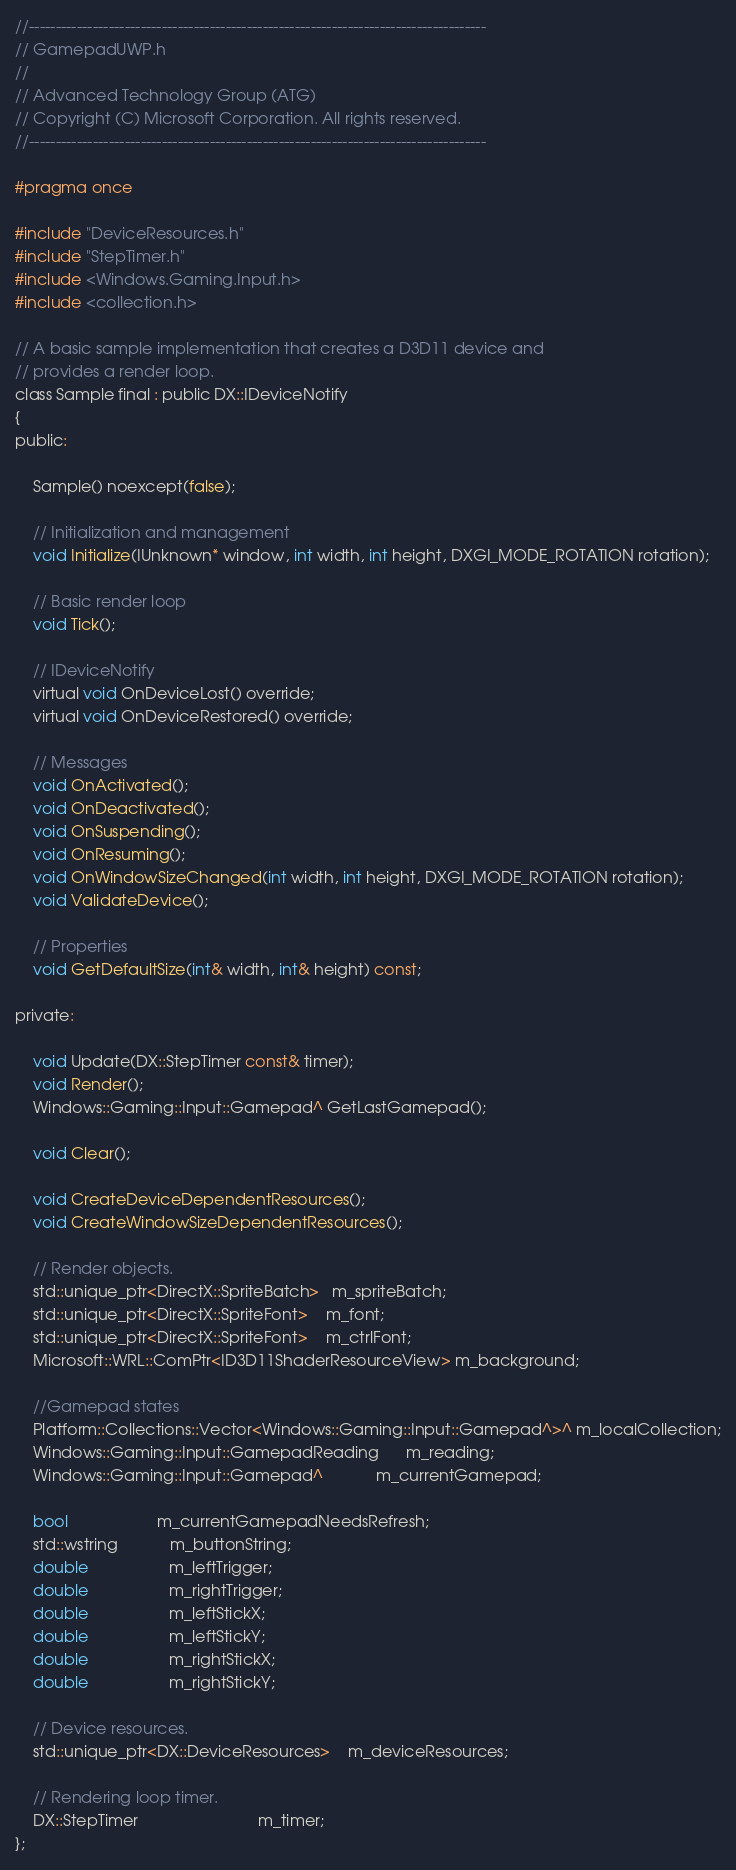Convert code to text. <code><loc_0><loc_0><loc_500><loc_500><_C_>//--------------------------------------------------------------------------------------
// GamepadUWP.h
//
// Advanced Technology Group (ATG)
// Copyright (C) Microsoft Corporation. All rights reserved.
//--------------------------------------------------------------------------------------

#pragma once

#include "DeviceResources.h"
#include "StepTimer.h"
#include <Windows.Gaming.Input.h>
#include <collection.h>

// A basic sample implementation that creates a D3D11 device and
// provides a render loop.
class Sample final : public DX::IDeviceNotify
{
public:

    Sample() noexcept(false);

    // Initialization and management
    void Initialize(IUnknown* window, int width, int height, DXGI_MODE_ROTATION rotation);

    // Basic render loop
    void Tick();

    // IDeviceNotify
    virtual void OnDeviceLost() override;
    virtual void OnDeviceRestored() override;

    // Messages
    void OnActivated();
    void OnDeactivated();
    void OnSuspending();
    void OnResuming();
    void OnWindowSizeChanged(int width, int height, DXGI_MODE_ROTATION rotation);
    void ValidateDevice();

    // Properties
    void GetDefaultSize(int& width, int& height) const;

private:

    void Update(DX::StepTimer const& timer);
    void Render();
    Windows::Gaming::Input::Gamepad^ GetLastGamepad();

    void Clear();

    void CreateDeviceDependentResources();
    void CreateWindowSizeDependentResources();

    // Render objects.
    std::unique_ptr<DirectX::SpriteBatch>   m_spriteBatch;
    std::unique_ptr<DirectX::SpriteFont>    m_font;
    std::unique_ptr<DirectX::SpriteFont>    m_ctrlFont;
    Microsoft::WRL::ComPtr<ID3D11ShaderResourceView> m_background;

    //Gamepad states
    Platform::Collections::Vector<Windows::Gaming::Input::Gamepad^>^ m_localCollection;
    Windows::Gaming::Input::GamepadReading      m_reading;
    Windows::Gaming::Input::Gamepad^            m_currentGamepad;

    bool                    m_currentGamepadNeedsRefresh;
    std::wstring            m_buttonString;
    double                  m_leftTrigger;
    double                  m_rightTrigger;
    double                  m_leftStickX;
    double                  m_leftStickY;
    double                  m_rightStickX;
    double                  m_rightStickY;

    // Device resources.
    std::unique_ptr<DX::DeviceResources>    m_deviceResources;

    // Rendering loop timer.
    DX::StepTimer                           m_timer;
};</code> 